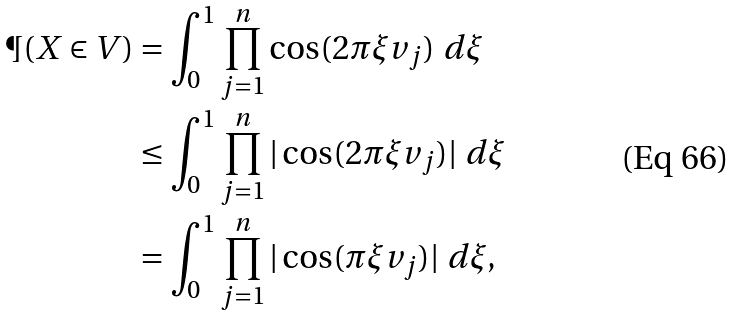<formula> <loc_0><loc_0><loc_500><loc_500>\P ( X \in V ) & = \int _ { 0 } ^ { 1 } \prod _ { j = 1 } ^ { n } \cos ( 2 \pi \xi v _ { j } ) \ d \xi \\ & \leq \int _ { 0 } ^ { 1 } \prod _ { j = 1 } ^ { n } | \cos ( 2 \pi \xi v _ { j } ) | \ d \xi \\ & = \int _ { 0 } ^ { 1 } \prod _ { j = 1 } ^ { n } | \cos ( \pi \xi v _ { j } ) | \ d \xi ,</formula> 